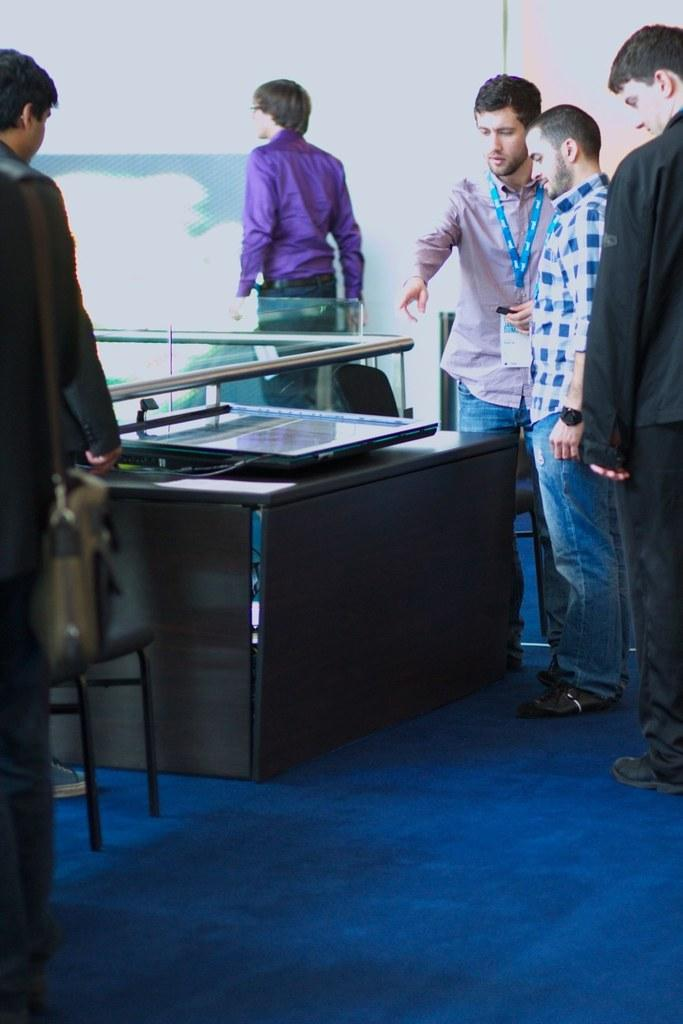How many people are in the image? There are multiple persons in the image. What can be seen on the table in the image? There is an object on the table in the image. Can you identify any specific item that one person is wearing? One person is wearing an ID card. What type of weather can be seen in the image? The provided facts do not mention any weather conditions, so it cannot be determined from the image. Can you tell me which vegetables are present in the image? There are no vegetables mentioned or visible in the image. 